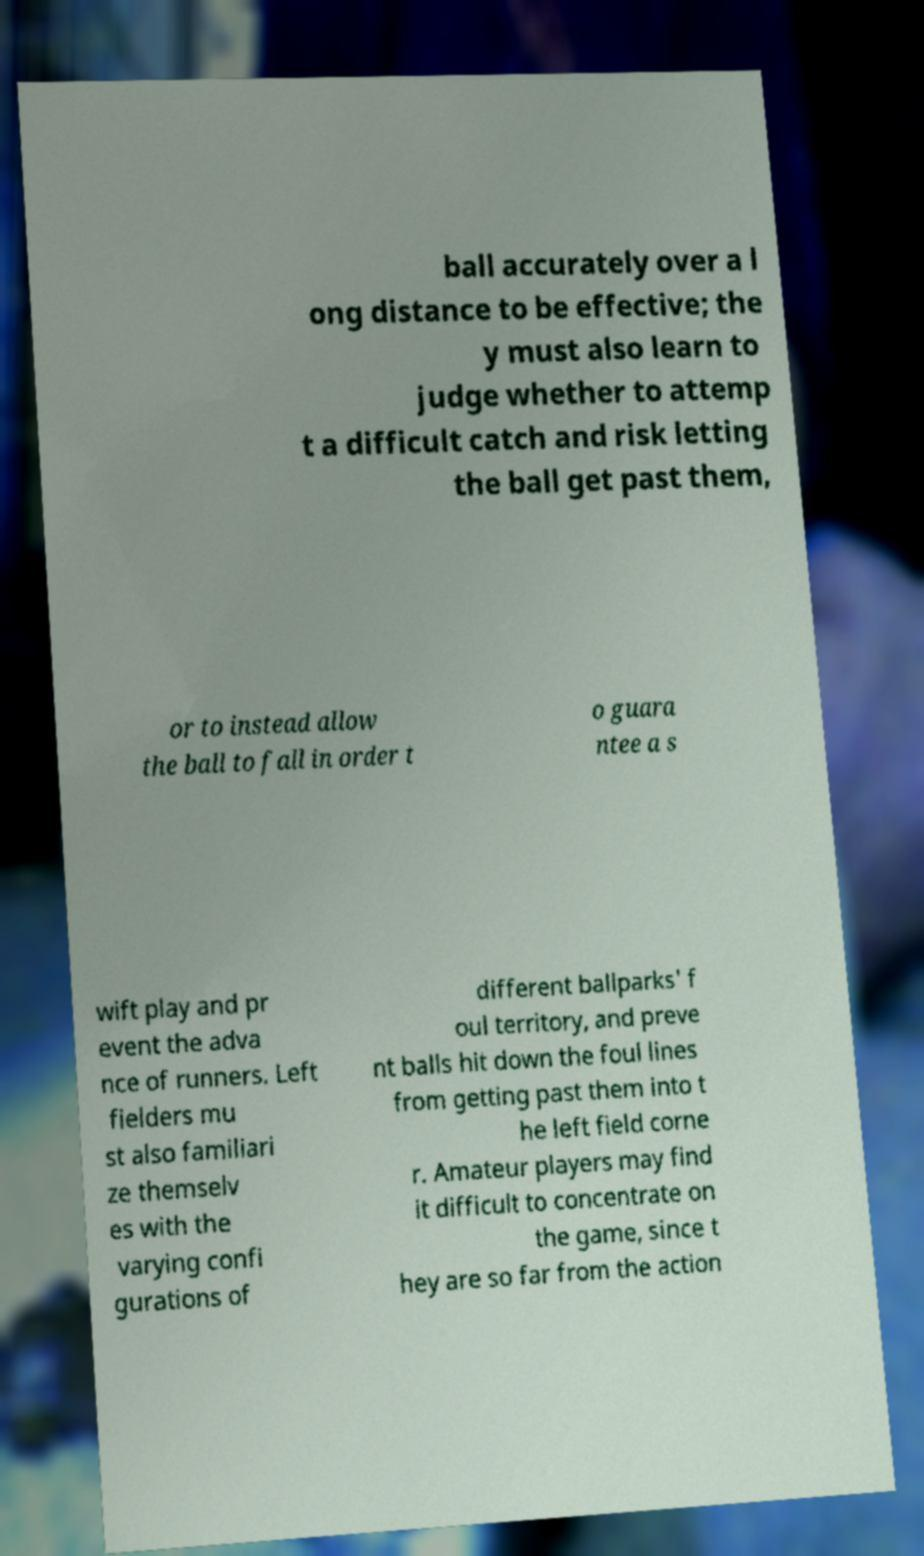Can you read and provide the text displayed in the image?This photo seems to have some interesting text. Can you extract and type it out for me? ball accurately over a l ong distance to be effective; the y must also learn to judge whether to attemp t a difficult catch and risk letting the ball get past them, or to instead allow the ball to fall in order t o guara ntee a s wift play and pr event the adva nce of runners. Left fielders mu st also familiari ze themselv es with the varying confi gurations of different ballparks' f oul territory, and preve nt balls hit down the foul lines from getting past them into t he left field corne r. Amateur players may find it difficult to concentrate on the game, since t hey are so far from the action 